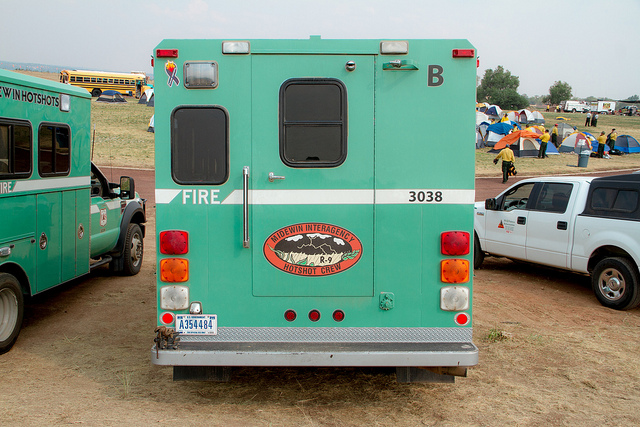Identify the text contained in this image. B 3038 FIRE HOTSHOT CREW INTERAGENCY MIDEWIN R.9 A354484 1RE WINHOTSHOTS 